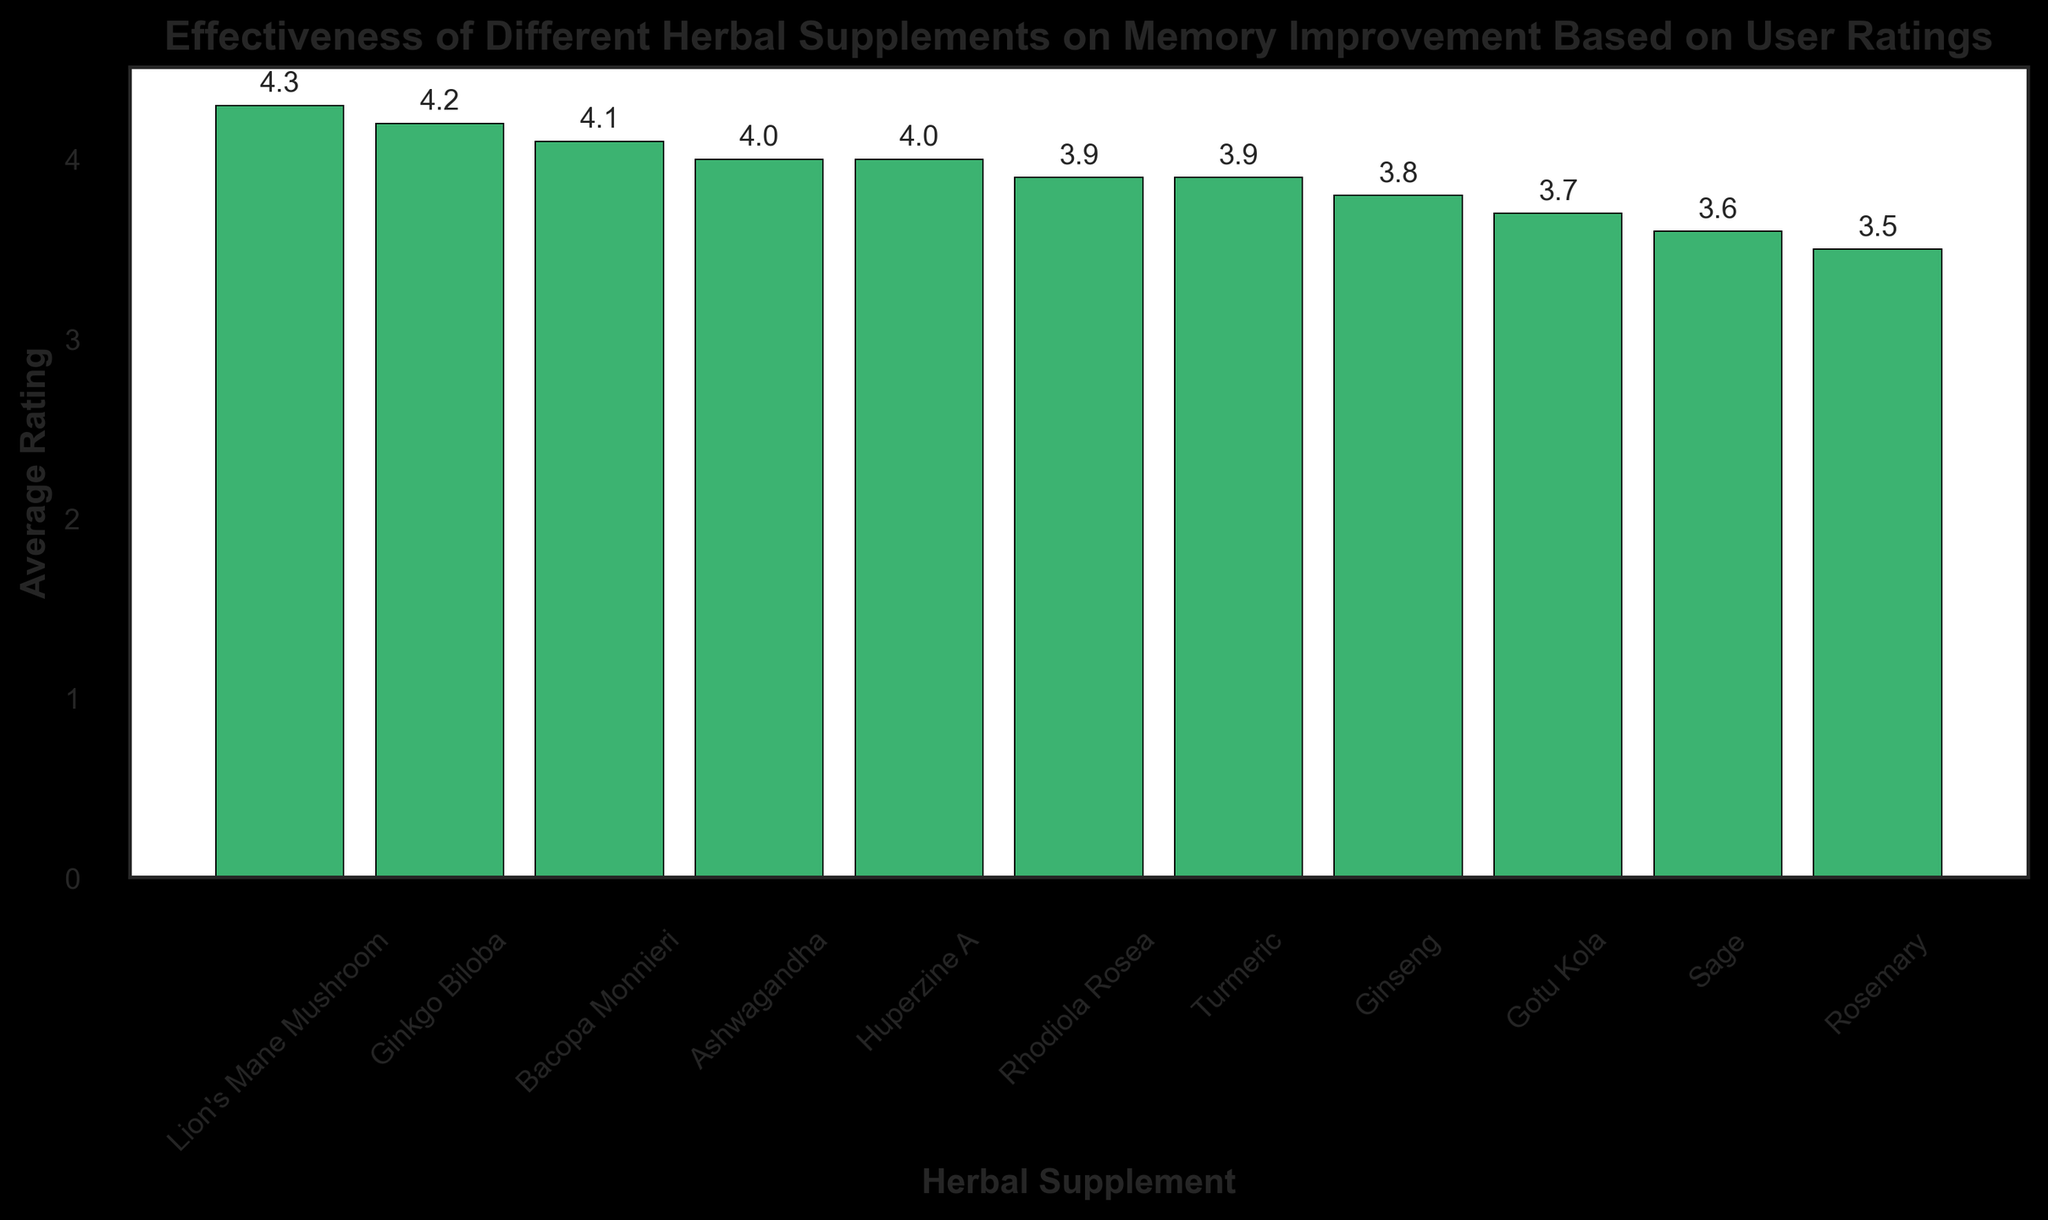Which herbal supplement has the highest average rating? Look for the tallest bar in the bar chart, which represents the supplement with the highest average rating.
Answer: Lion's Mane Mushroom How many supplements have an average rating of 4.0 or higher? Count the number of bars with height 4.0 or higher by observing their value annotations or positions on the Y-axis.
Answer: 5 Which supplement has more reviews: Ginkgo Biloba or Ginseng? Look at the dataset values directly as the number of reviews isn't shown in the bar chart. Compare the numbers given: Ginkgo Biloba has 1200, and Ginseng has 1100 reviews.
Answer: Ginkgo Biloba What is the average rating difference between the highest and lowest rated supplements? Identify the highest rating (Lion's Mane Mushroom at 4.3) and the lowest rating (Rosemary at 3.5) from the chart. Subtract the lowest rating from the highest rating.
Answer: 0.8 Which supplement has a higher average rating: Rhodiola Rosea or Turmeric? Compare the height of the bars for Rhodiola Rosea (3.9) and Turmeric (3.9) based on their annotations.
Answer: Same What is the combined average rating of Ginkgo Biloba, Bacopa Monnieri, and Ashwagandha? Add the average ratings of Ginkgo Biloba (4.2), Bacopa Monnieri (4.1), and Ashwagandha (4.0).
Answer: 12.3 How does Sage compare to Gotu Kola in terms of average rating? Compare the height of the bars for Sage (3.6) and Gotu Kola (3.7) to see which is taller.
Answer: Lower If a new supplement had an average rating that was the median of the presented supplements, what would that rating be? Identify the middle value in the sorted list of average ratings: 3.5, 3.6, 3.7, 3.8, 3.9, **3.9**, 4.0, 4.0, 4.1, 4.2, 4.3.
Answer: 3.9 